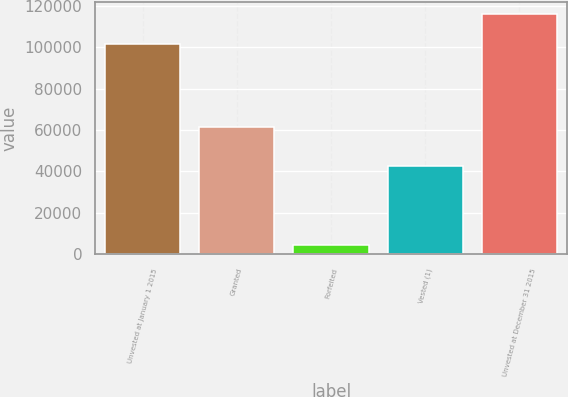Convert chart. <chart><loc_0><loc_0><loc_500><loc_500><bar_chart><fcel>Unvested at January 1 2015<fcel>Granted<fcel>Forfeited<fcel>Vested (1)<fcel>Unvested at December 31 2015<nl><fcel>101723<fcel>61611<fcel>4690<fcel>42584<fcel>116060<nl></chart> 